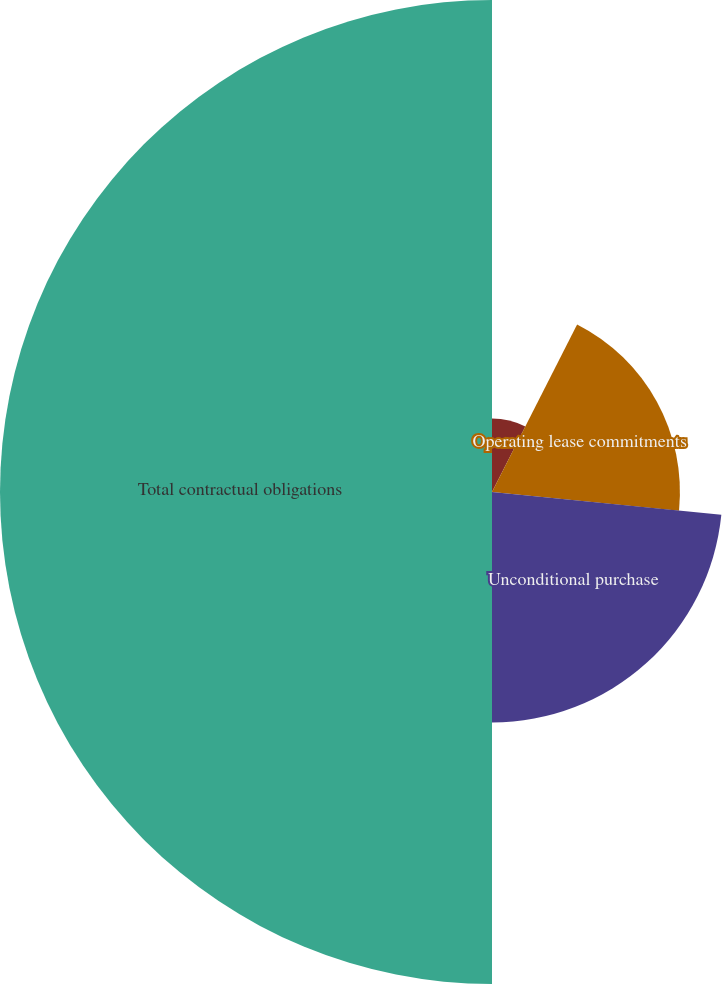Convert chart to OTSL. <chart><loc_0><loc_0><loc_500><loc_500><pie_chart><fcel>Debt service^(1)<fcel>Operating lease commitments<fcel>Unconditional purchase<fcel>Total contractual obligations<nl><fcel>7.48%<fcel>19.1%<fcel>23.42%<fcel>50.0%<nl></chart> 